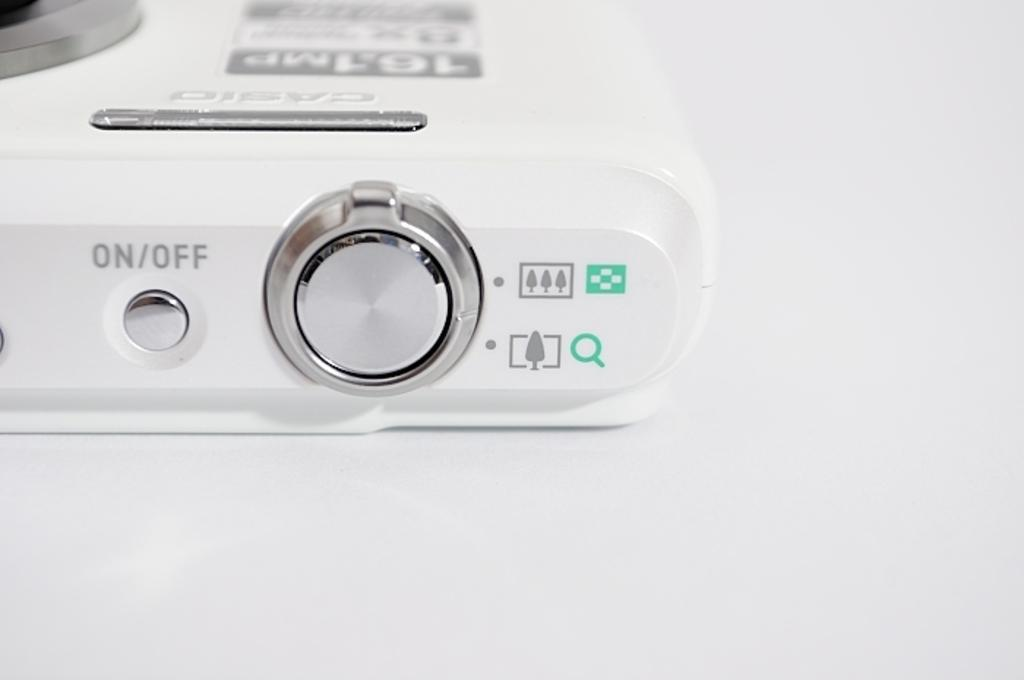Provide a one-sentence caption for the provided image. A casio camera has an on/off button on the top. 